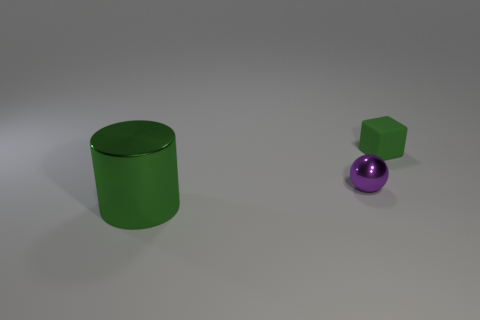Are there any other things that have the same size as the green shiny cylinder?
Make the answer very short. No. There is a large thing that is the same color as the small rubber thing; what is it made of?
Keep it short and to the point. Metal. Does the tiny object in front of the small green cube have the same color as the thing in front of the purple sphere?
Ensure brevity in your answer.  No. What number of brown objects are either large shiny cylinders or tiny metallic balls?
Your response must be concise. 0. How many cyan metallic things have the same size as the green rubber object?
Give a very brief answer. 0. Are the green thing behind the big shiny cylinder and the green cylinder made of the same material?
Provide a succinct answer. No. There is a tiny object to the left of the tiny matte block; are there any green objects that are behind it?
Your response must be concise. Yes. Are there more small purple objects that are to the right of the green matte thing than cylinders that are on the left side of the small metallic thing?
Provide a short and direct response. No. There is a large green object that is made of the same material as the tiny purple thing; what shape is it?
Your answer should be very brief. Cylinder. Are there more big cylinders on the right side of the big green metal object than purple shiny things?
Your response must be concise. No. 